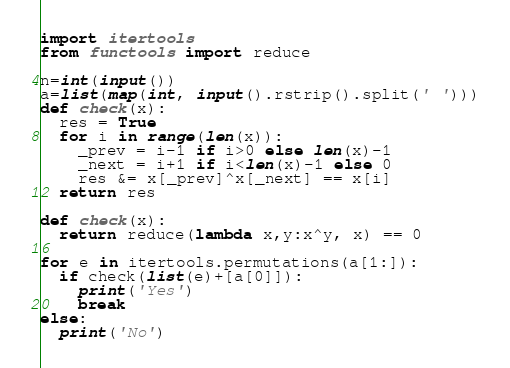Convert code to text. <code><loc_0><loc_0><loc_500><loc_500><_Python_>import itertools
from functools import reduce
 
n=int(input())
a=list(map(int, input().rstrip().split(' ')))
def check(x):
  res = True
  for i in range(len(x)):
    _prev = i-1 if i>0 else len(x)-1
    _next = i+1 if i<len(x)-1 else 0
    res &= x[_prev]^x[_next] == x[i]
  return res

def check(x):
  return reduce(lambda x,y:x^y, x) == 0

for e in itertools.permutations(a[1:]):
  if check(list(e)+[a[0]]):
    print('Yes')
    break
else:
  print('No')</code> 